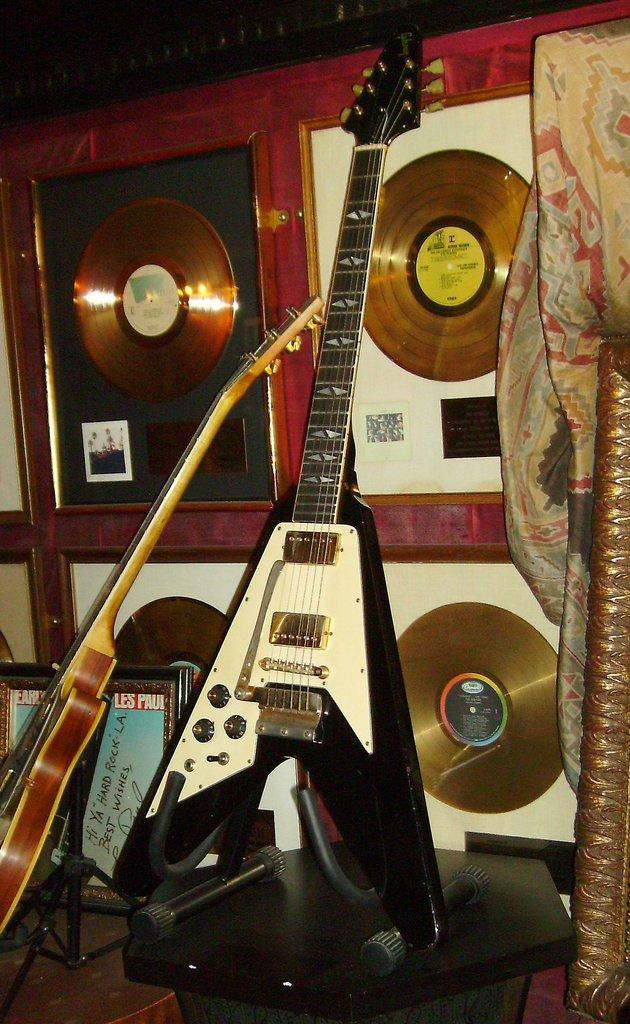What type of musical instruments are in the image? There is an electric guitar and a normal guitar in the image. What else can be seen in the image besides the guitars? There are CDs and awards in the image. What is the purpose of the piece of cloth on the right side of the image? The purpose of the piece of cloth is not clear from the image, but it could be used for decoration or as a backdrop. What type of ship can be seen sailing in the background of the image? There is no ship visible in the image; it only features guitars, CDs, awards, and a piece of cloth. 